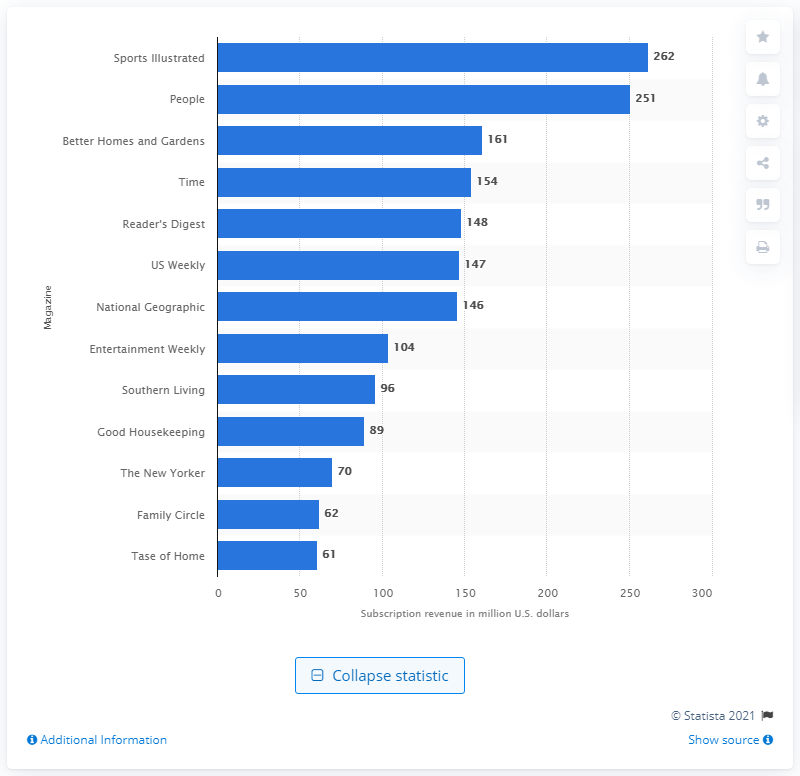Specify some key components in this picture. In 2016, Sports Illustrated generated approximately $262 million in subscription revenue. In 2016, Sports Illustrated generated subscription revenue of 262 million U.S. dollars. 